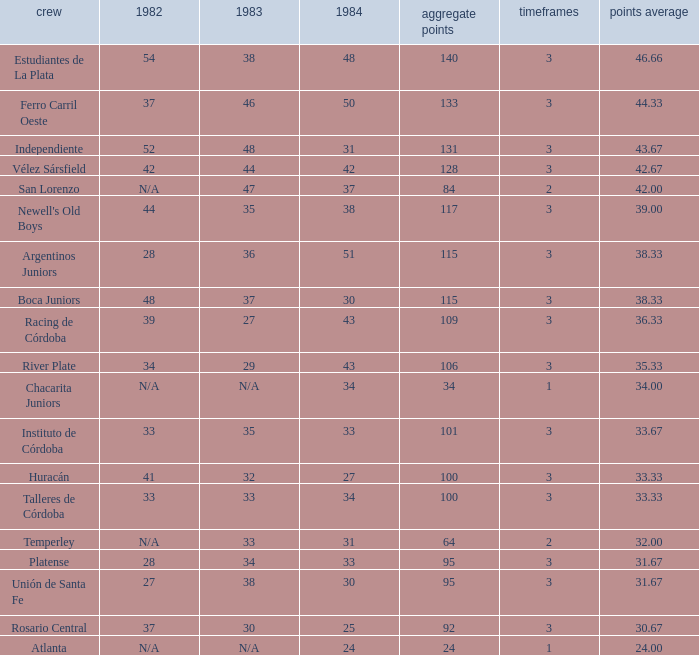What is the total for 1984 for the team with 100 points total and more than 3 seasons? None. Give me the full table as a dictionary. {'header': ['crew', '1982', '1983', '1984', 'aggregate points', 'timeframes', 'points average'], 'rows': [['Estudiantes de La Plata', '54', '38', '48', '140', '3', '46.66'], ['Ferro Carril Oeste', '37', '46', '50', '133', '3', '44.33'], ['Independiente', '52', '48', '31', '131', '3', '43.67'], ['Vélez Sársfield', '42', '44', '42', '128', '3', '42.67'], ['San Lorenzo', 'N/A', '47', '37', '84', '2', '42.00'], ["Newell's Old Boys", '44', '35', '38', '117', '3', '39.00'], ['Argentinos Juniors', '28', '36', '51', '115', '3', '38.33'], ['Boca Juniors', '48', '37', '30', '115', '3', '38.33'], ['Racing de Córdoba', '39', '27', '43', '109', '3', '36.33'], ['River Plate', '34', '29', '43', '106', '3', '35.33'], ['Chacarita Juniors', 'N/A', 'N/A', '34', '34', '1', '34.00'], ['Instituto de Córdoba', '33', '35', '33', '101', '3', '33.67'], ['Huracán', '41', '32', '27', '100', '3', '33.33'], ['Talleres de Córdoba', '33', '33', '34', '100', '3', '33.33'], ['Temperley', 'N/A', '33', '31', '64', '2', '32.00'], ['Platense', '28', '34', '33', '95', '3', '31.67'], ['Unión de Santa Fe', '27', '38', '30', '95', '3', '31.67'], ['Rosario Central', '37', '30', '25', '92', '3', '30.67'], ['Atlanta', 'N/A', 'N/A', '24', '24', '1', '24.00']]} 